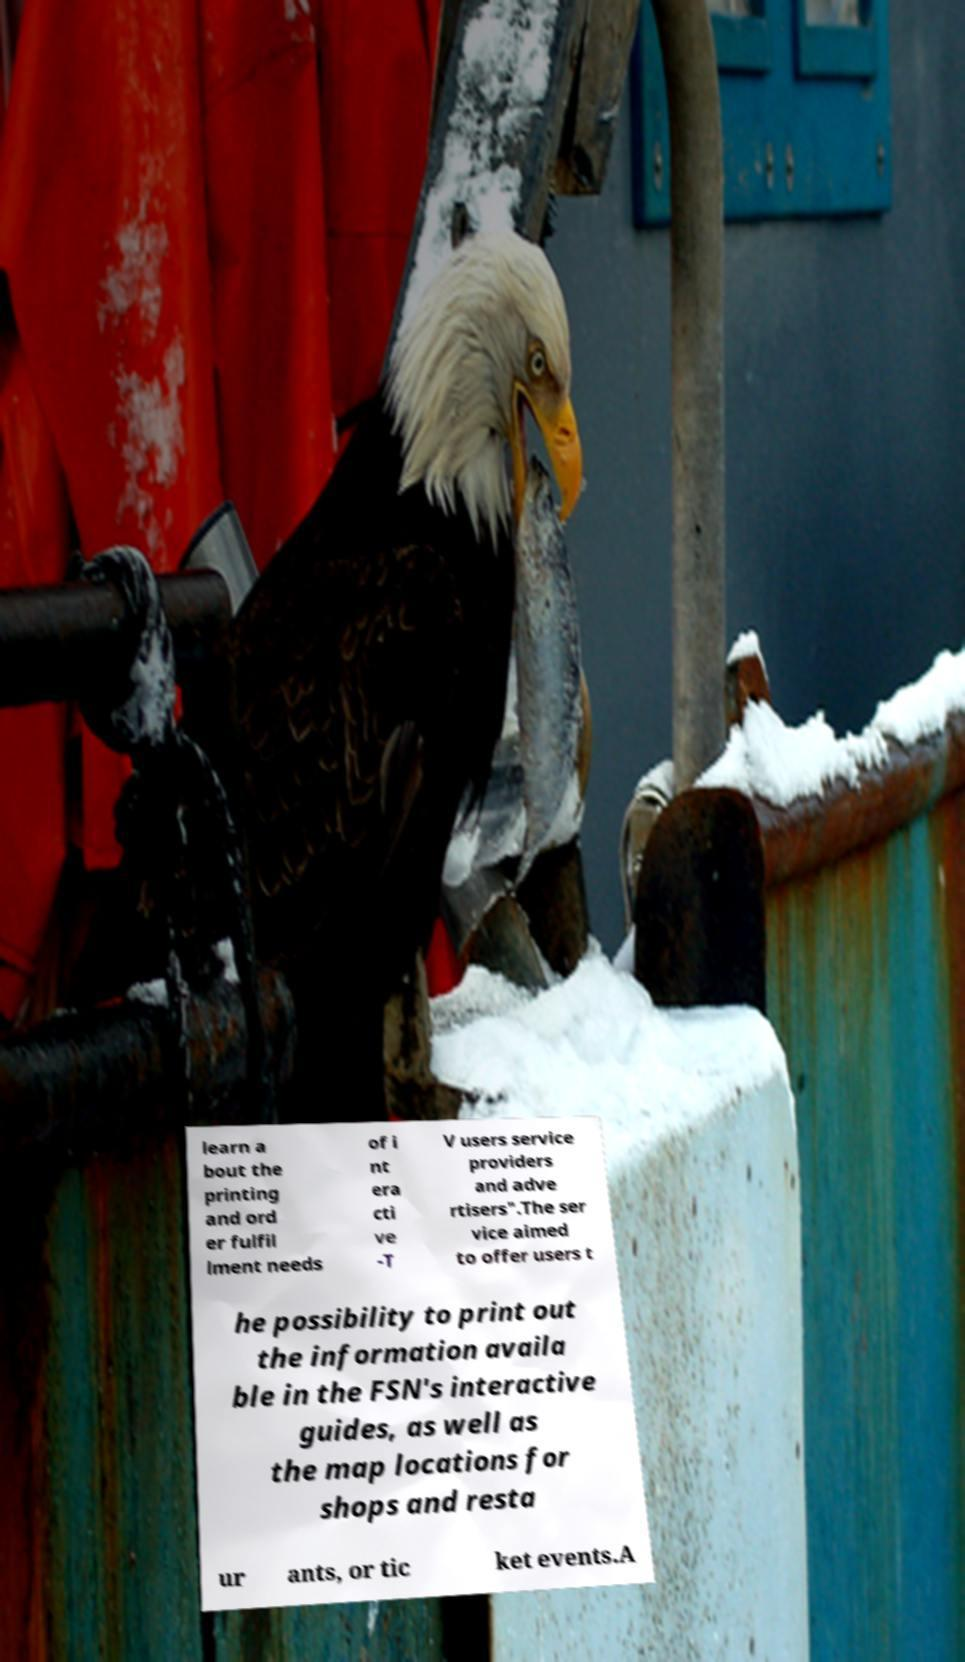Can you accurately transcribe the text from the provided image for me? learn a bout the printing and ord er fulfil lment needs of i nt era cti ve -T V users service providers and adve rtisers".The ser vice aimed to offer users t he possibility to print out the information availa ble in the FSN's interactive guides, as well as the map locations for shops and resta ur ants, or tic ket events.A 